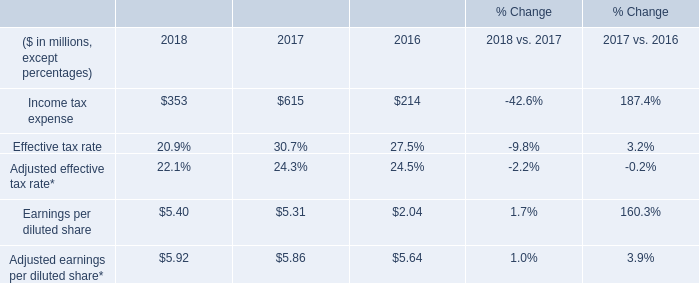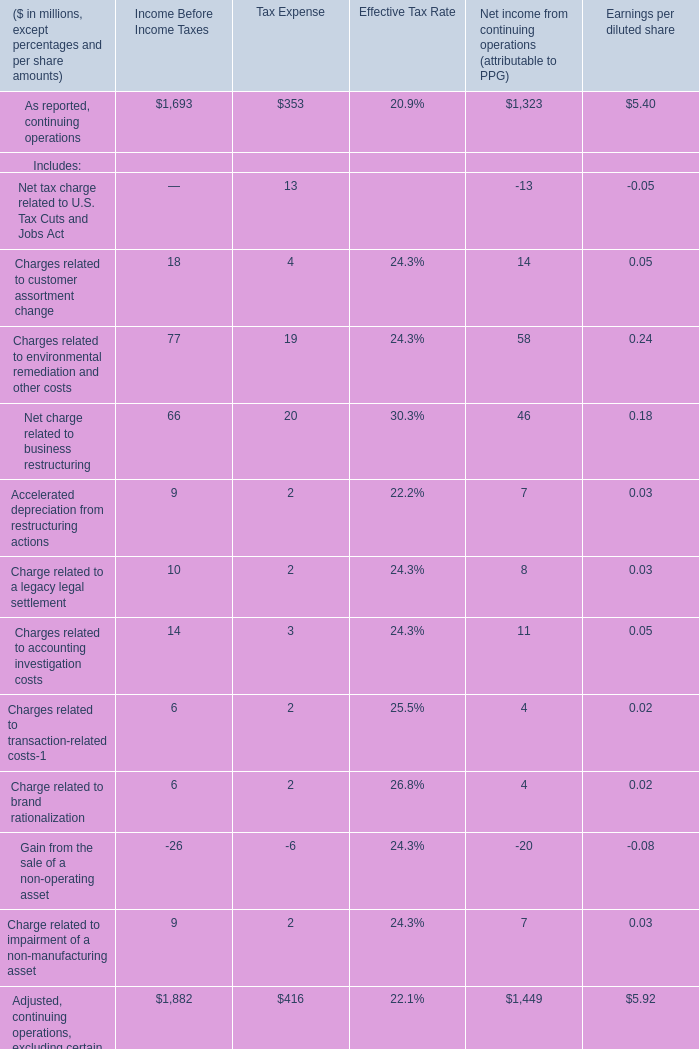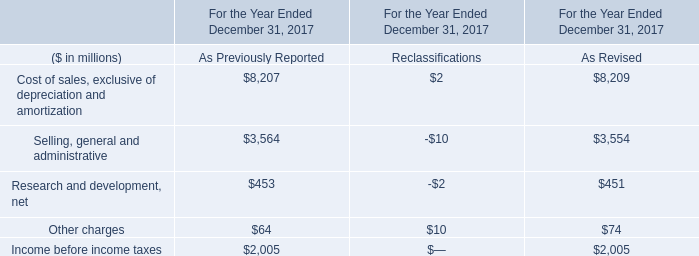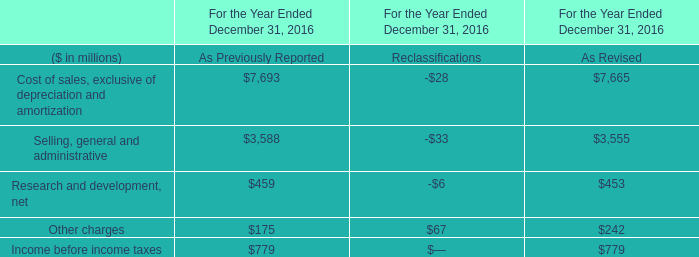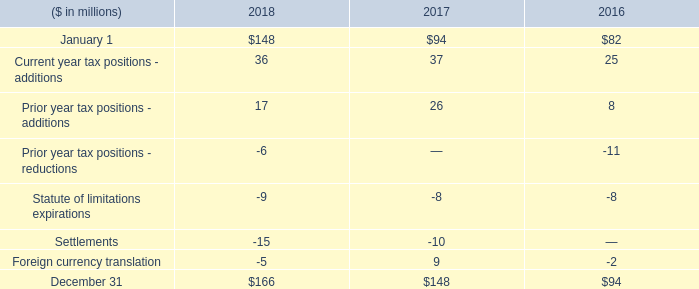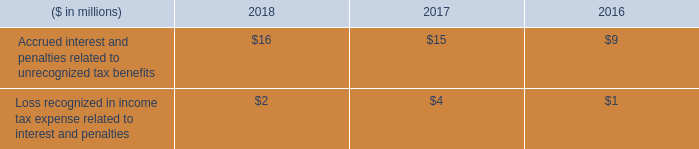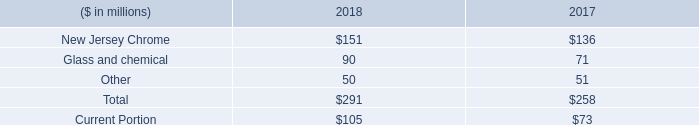Does the value of Income tax expense in 2018 greater than that in 2017? 
Answer: no. 